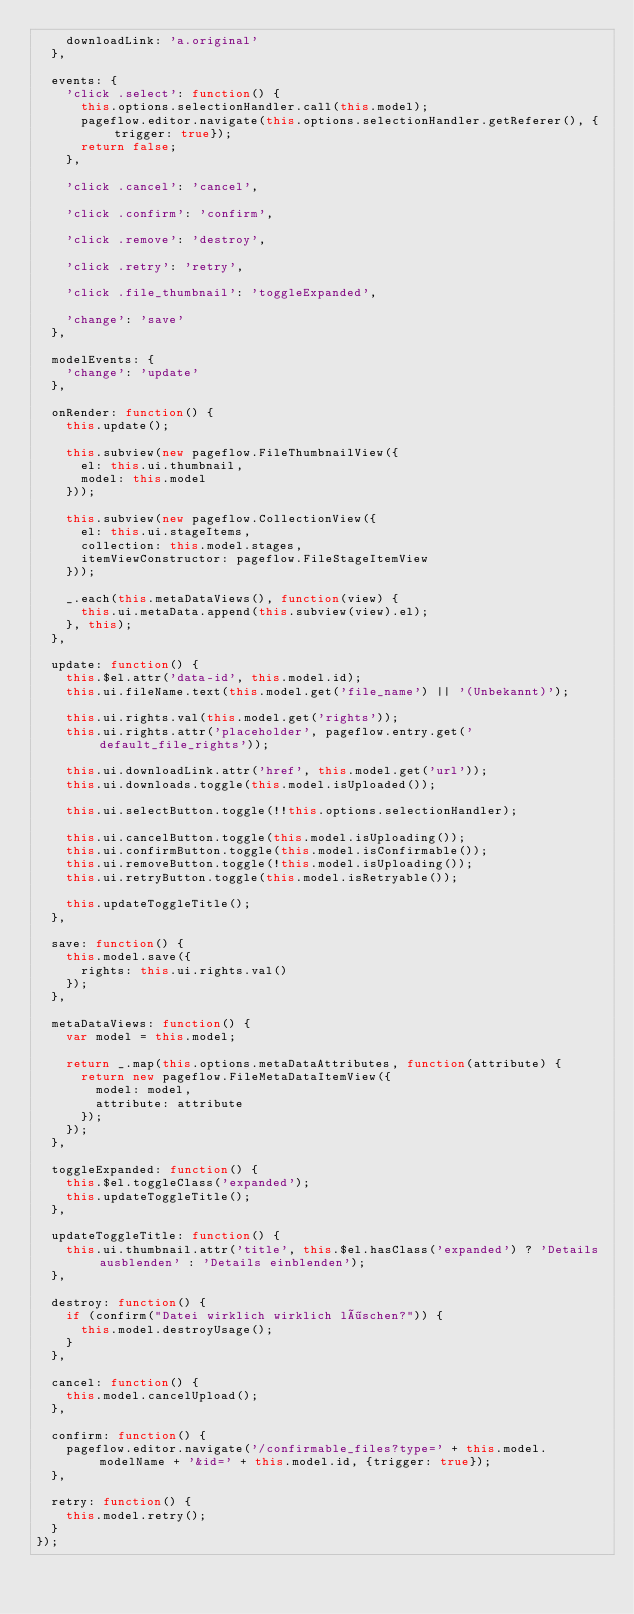Convert code to text. <code><loc_0><loc_0><loc_500><loc_500><_JavaScript_>    downloadLink: 'a.original'
  },

  events: {
    'click .select': function() {
      this.options.selectionHandler.call(this.model);
      pageflow.editor.navigate(this.options.selectionHandler.getReferer(), {trigger: true});
      return false;
    },

    'click .cancel': 'cancel',

    'click .confirm': 'confirm',

    'click .remove': 'destroy',

    'click .retry': 'retry',

    'click .file_thumbnail': 'toggleExpanded',

    'change': 'save'
  },

  modelEvents: {
    'change': 'update'
  },

  onRender: function() {
    this.update();

    this.subview(new pageflow.FileThumbnailView({
      el: this.ui.thumbnail,
      model: this.model
    }));

    this.subview(new pageflow.CollectionView({
      el: this.ui.stageItems,
      collection: this.model.stages,
      itemViewConstructor: pageflow.FileStageItemView
    }));

    _.each(this.metaDataViews(), function(view) {
      this.ui.metaData.append(this.subview(view).el);
    }, this);
  },

  update: function() {
    this.$el.attr('data-id', this.model.id);
    this.ui.fileName.text(this.model.get('file_name') || '(Unbekannt)');

    this.ui.rights.val(this.model.get('rights'));
    this.ui.rights.attr('placeholder', pageflow.entry.get('default_file_rights'));

    this.ui.downloadLink.attr('href', this.model.get('url'));
    this.ui.downloads.toggle(this.model.isUploaded());

    this.ui.selectButton.toggle(!!this.options.selectionHandler);

    this.ui.cancelButton.toggle(this.model.isUploading());
    this.ui.confirmButton.toggle(this.model.isConfirmable());
    this.ui.removeButton.toggle(!this.model.isUploading());
    this.ui.retryButton.toggle(this.model.isRetryable());

    this.updateToggleTitle();
  },

  save: function() {
    this.model.save({
      rights: this.ui.rights.val()
    });
  },

  metaDataViews: function() {
    var model = this.model;

    return _.map(this.options.metaDataAttributes, function(attribute) {
      return new pageflow.FileMetaDataItemView({
        model: model,
        attribute: attribute
      });
    });
  },

  toggleExpanded: function() {
    this.$el.toggleClass('expanded');
    this.updateToggleTitle();
  },

  updateToggleTitle: function() {
    this.ui.thumbnail.attr('title', this.$el.hasClass('expanded') ? 'Details ausblenden' : 'Details einblenden');
  },

  destroy: function() {
    if (confirm("Datei wirklich wirklich löschen?")) {
      this.model.destroyUsage();
    }
  },

  cancel: function() {
    this.model.cancelUpload();
  },

  confirm: function() {
    pageflow.editor.navigate('/confirmable_files?type=' + this.model.modelName + '&id=' + this.model.id, {trigger: true});
  },

  retry: function() {
    this.model.retry();
  }
});
</code> 